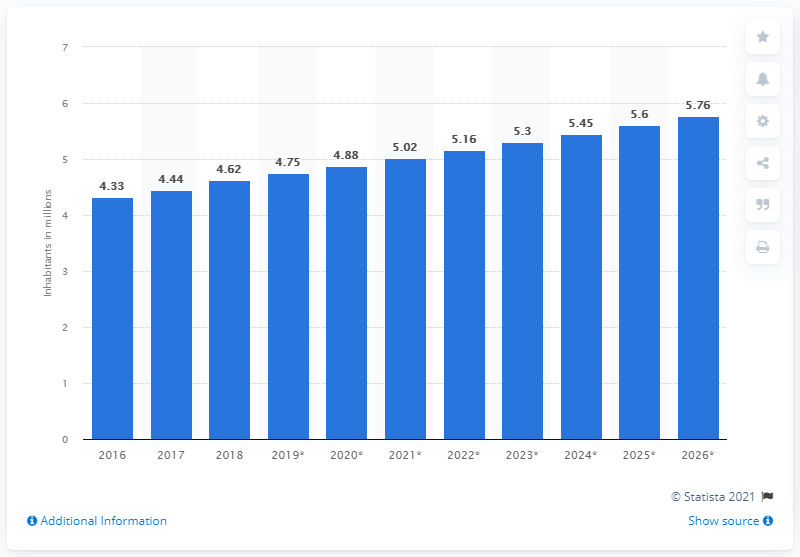Can you describe the trend in Kuwait's population from 2016 to 2026 according to this chart? The bar chart illustrates a steady increase in Kuwait's population over the decade from 2016 to 2026. Starting from approximately 4.33 million people in 2016, there's a gradual rise each year leading to a projected population of 5.76 million inhabitants by 2026. 